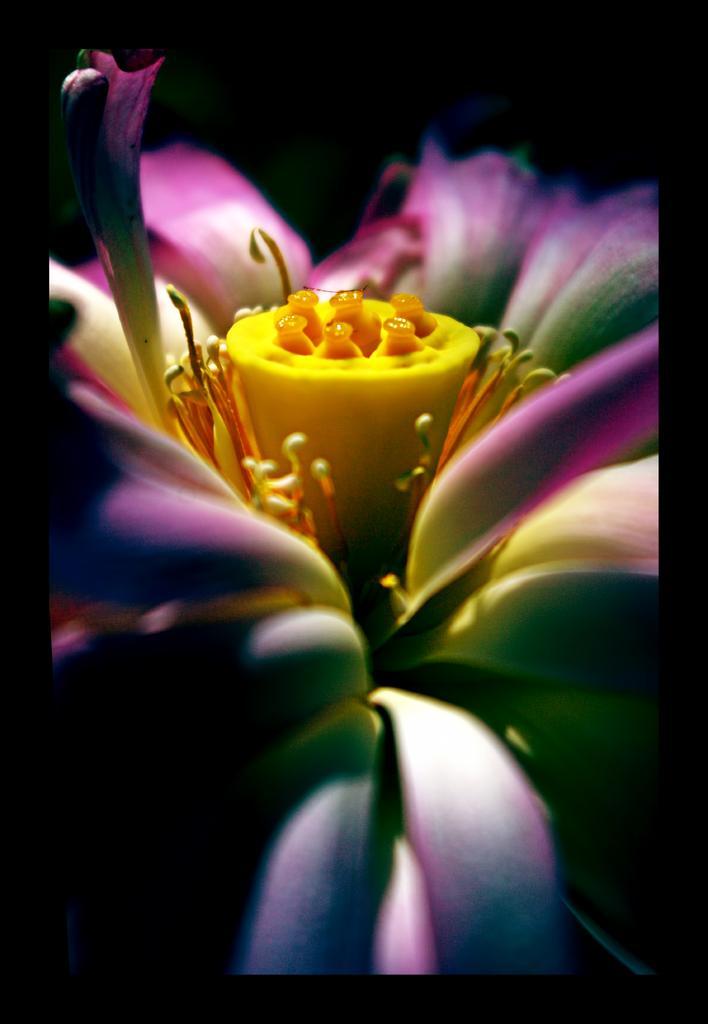In one or two sentences, can you explain what this image depicts? This image consists of a flower. It is in purple color. 